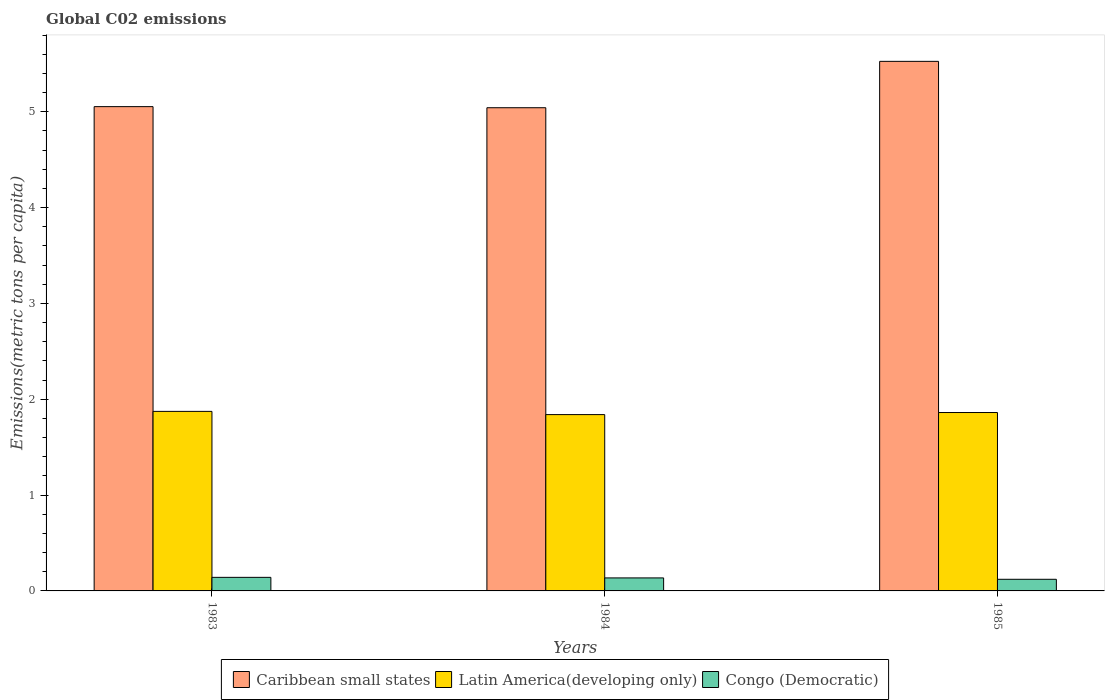Are the number of bars on each tick of the X-axis equal?
Your answer should be compact. Yes. In how many cases, is the number of bars for a given year not equal to the number of legend labels?
Your answer should be compact. 0. What is the amount of CO2 emitted in in Caribbean small states in 1984?
Make the answer very short. 5.04. Across all years, what is the maximum amount of CO2 emitted in in Congo (Democratic)?
Provide a short and direct response. 0.14. Across all years, what is the minimum amount of CO2 emitted in in Latin America(developing only)?
Give a very brief answer. 1.84. In which year was the amount of CO2 emitted in in Latin America(developing only) minimum?
Provide a short and direct response. 1984. What is the total amount of CO2 emitted in in Latin America(developing only) in the graph?
Your answer should be very brief. 5.57. What is the difference between the amount of CO2 emitted in in Caribbean small states in 1983 and that in 1984?
Your answer should be very brief. 0.01. What is the difference between the amount of CO2 emitted in in Caribbean small states in 1983 and the amount of CO2 emitted in in Latin America(developing only) in 1985?
Ensure brevity in your answer.  3.19. What is the average amount of CO2 emitted in in Latin America(developing only) per year?
Offer a very short reply. 1.86. In the year 1985, what is the difference between the amount of CO2 emitted in in Congo (Democratic) and amount of CO2 emitted in in Latin America(developing only)?
Ensure brevity in your answer.  -1.74. What is the ratio of the amount of CO2 emitted in in Congo (Democratic) in 1984 to that in 1985?
Ensure brevity in your answer.  1.12. What is the difference between the highest and the second highest amount of CO2 emitted in in Congo (Democratic)?
Ensure brevity in your answer.  0.01. What is the difference between the highest and the lowest amount of CO2 emitted in in Latin America(developing only)?
Your answer should be very brief. 0.03. In how many years, is the amount of CO2 emitted in in Caribbean small states greater than the average amount of CO2 emitted in in Caribbean small states taken over all years?
Make the answer very short. 1. Is the sum of the amount of CO2 emitted in in Latin America(developing only) in 1984 and 1985 greater than the maximum amount of CO2 emitted in in Caribbean small states across all years?
Keep it short and to the point. No. What does the 3rd bar from the left in 1985 represents?
Keep it short and to the point. Congo (Democratic). What does the 1st bar from the right in 1984 represents?
Make the answer very short. Congo (Democratic). How many bars are there?
Make the answer very short. 9. Are all the bars in the graph horizontal?
Offer a terse response. No. Are the values on the major ticks of Y-axis written in scientific E-notation?
Ensure brevity in your answer.  No. Does the graph contain any zero values?
Offer a very short reply. No. What is the title of the graph?
Offer a terse response. Global C02 emissions. What is the label or title of the Y-axis?
Give a very brief answer. Emissions(metric tons per capita). What is the Emissions(metric tons per capita) of Caribbean small states in 1983?
Provide a short and direct response. 5.05. What is the Emissions(metric tons per capita) of Latin America(developing only) in 1983?
Provide a succinct answer. 1.87. What is the Emissions(metric tons per capita) of Congo (Democratic) in 1983?
Make the answer very short. 0.14. What is the Emissions(metric tons per capita) of Caribbean small states in 1984?
Provide a succinct answer. 5.04. What is the Emissions(metric tons per capita) in Latin America(developing only) in 1984?
Offer a very short reply. 1.84. What is the Emissions(metric tons per capita) of Congo (Democratic) in 1984?
Provide a short and direct response. 0.14. What is the Emissions(metric tons per capita) of Caribbean small states in 1985?
Ensure brevity in your answer.  5.53. What is the Emissions(metric tons per capita) of Latin America(developing only) in 1985?
Your answer should be compact. 1.86. What is the Emissions(metric tons per capita) in Congo (Democratic) in 1985?
Offer a terse response. 0.12. Across all years, what is the maximum Emissions(metric tons per capita) in Caribbean small states?
Your response must be concise. 5.53. Across all years, what is the maximum Emissions(metric tons per capita) of Latin America(developing only)?
Give a very brief answer. 1.87. Across all years, what is the maximum Emissions(metric tons per capita) of Congo (Democratic)?
Offer a terse response. 0.14. Across all years, what is the minimum Emissions(metric tons per capita) of Caribbean small states?
Keep it short and to the point. 5.04. Across all years, what is the minimum Emissions(metric tons per capita) in Latin America(developing only)?
Provide a succinct answer. 1.84. Across all years, what is the minimum Emissions(metric tons per capita) of Congo (Democratic)?
Keep it short and to the point. 0.12. What is the total Emissions(metric tons per capita) of Caribbean small states in the graph?
Provide a short and direct response. 15.62. What is the total Emissions(metric tons per capita) in Latin America(developing only) in the graph?
Provide a succinct answer. 5.57. What is the total Emissions(metric tons per capita) in Congo (Democratic) in the graph?
Your answer should be very brief. 0.4. What is the difference between the Emissions(metric tons per capita) of Caribbean small states in 1983 and that in 1984?
Keep it short and to the point. 0.01. What is the difference between the Emissions(metric tons per capita) of Latin America(developing only) in 1983 and that in 1984?
Make the answer very short. 0.03. What is the difference between the Emissions(metric tons per capita) of Congo (Democratic) in 1983 and that in 1984?
Ensure brevity in your answer.  0.01. What is the difference between the Emissions(metric tons per capita) in Caribbean small states in 1983 and that in 1985?
Ensure brevity in your answer.  -0.47. What is the difference between the Emissions(metric tons per capita) in Latin America(developing only) in 1983 and that in 1985?
Offer a terse response. 0.01. What is the difference between the Emissions(metric tons per capita) of Congo (Democratic) in 1983 and that in 1985?
Provide a short and direct response. 0.02. What is the difference between the Emissions(metric tons per capita) of Caribbean small states in 1984 and that in 1985?
Your response must be concise. -0.48. What is the difference between the Emissions(metric tons per capita) of Latin America(developing only) in 1984 and that in 1985?
Ensure brevity in your answer.  -0.02. What is the difference between the Emissions(metric tons per capita) of Congo (Democratic) in 1984 and that in 1985?
Make the answer very short. 0.01. What is the difference between the Emissions(metric tons per capita) of Caribbean small states in 1983 and the Emissions(metric tons per capita) of Latin America(developing only) in 1984?
Keep it short and to the point. 3.21. What is the difference between the Emissions(metric tons per capita) in Caribbean small states in 1983 and the Emissions(metric tons per capita) in Congo (Democratic) in 1984?
Give a very brief answer. 4.92. What is the difference between the Emissions(metric tons per capita) of Latin America(developing only) in 1983 and the Emissions(metric tons per capita) of Congo (Democratic) in 1984?
Make the answer very short. 1.74. What is the difference between the Emissions(metric tons per capita) in Caribbean small states in 1983 and the Emissions(metric tons per capita) in Latin America(developing only) in 1985?
Make the answer very short. 3.19. What is the difference between the Emissions(metric tons per capita) in Caribbean small states in 1983 and the Emissions(metric tons per capita) in Congo (Democratic) in 1985?
Your response must be concise. 4.93. What is the difference between the Emissions(metric tons per capita) in Latin America(developing only) in 1983 and the Emissions(metric tons per capita) in Congo (Democratic) in 1985?
Provide a succinct answer. 1.75. What is the difference between the Emissions(metric tons per capita) of Caribbean small states in 1984 and the Emissions(metric tons per capita) of Latin America(developing only) in 1985?
Offer a very short reply. 3.18. What is the difference between the Emissions(metric tons per capita) of Caribbean small states in 1984 and the Emissions(metric tons per capita) of Congo (Democratic) in 1985?
Provide a short and direct response. 4.92. What is the difference between the Emissions(metric tons per capita) in Latin America(developing only) in 1984 and the Emissions(metric tons per capita) in Congo (Democratic) in 1985?
Your response must be concise. 1.72. What is the average Emissions(metric tons per capita) in Caribbean small states per year?
Give a very brief answer. 5.21. What is the average Emissions(metric tons per capita) of Latin America(developing only) per year?
Offer a very short reply. 1.86. What is the average Emissions(metric tons per capita) of Congo (Democratic) per year?
Offer a very short reply. 0.13. In the year 1983, what is the difference between the Emissions(metric tons per capita) in Caribbean small states and Emissions(metric tons per capita) in Latin America(developing only)?
Provide a succinct answer. 3.18. In the year 1983, what is the difference between the Emissions(metric tons per capita) in Caribbean small states and Emissions(metric tons per capita) in Congo (Democratic)?
Make the answer very short. 4.91. In the year 1983, what is the difference between the Emissions(metric tons per capita) in Latin America(developing only) and Emissions(metric tons per capita) in Congo (Democratic)?
Your response must be concise. 1.73. In the year 1984, what is the difference between the Emissions(metric tons per capita) of Caribbean small states and Emissions(metric tons per capita) of Latin America(developing only)?
Provide a succinct answer. 3.2. In the year 1984, what is the difference between the Emissions(metric tons per capita) in Caribbean small states and Emissions(metric tons per capita) in Congo (Democratic)?
Ensure brevity in your answer.  4.91. In the year 1984, what is the difference between the Emissions(metric tons per capita) in Latin America(developing only) and Emissions(metric tons per capita) in Congo (Democratic)?
Ensure brevity in your answer.  1.7. In the year 1985, what is the difference between the Emissions(metric tons per capita) in Caribbean small states and Emissions(metric tons per capita) in Latin America(developing only)?
Offer a terse response. 3.66. In the year 1985, what is the difference between the Emissions(metric tons per capita) of Caribbean small states and Emissions(metric tons per capita) of Congo (Democratic)?
Offer a very short reply. 5.4. In the year 1985, what is the difference between the Emissions(metric tons per capita) in Latin America(developing only) and Emissions(metric tons per capita) in Congo (Democratic)?
Keep it short and to the point. 1.74. What is the ratio of the Emissions(metric tons per capita) in Caribbean small states in 1983 to that in 1984?
Provide a succinct answer. 1. What is the ratio of the Emissions(metric tons per capita) in Latin America(developing only) in 1983 to that in 1984?
Ensure brevity in your answer.  1.02. What is the ratio of the Emissions(metric tons per capita) in Congo (Democratic) in 1983 to that in 1984?
Keep it short and to the point. 1.04. What is the ratio of the Emissions(metric tons per capita) in Caribbean small states in 1983 to that in 1985?
Your answer should be very brief. 0.91. What is the ratio of the Emissions(metric tons per capita) of Latin America(developing only) in 1983 to that in 1985?
Your response must be concise. 1.01. What is the ratio of the Emissions(metric tons per capita) of Congo (Democratic) in 1983 to that in 1985?
Your answer should be compact. 1.17. What is the ratio of the Emissions(metric tons per capita) of Caribbean small states in 1984 to that in 1985?
Ensure brevity in your answer.  0.91. What is the ratio of the Emissions(metric tons per capita) in Latin America(developing only) in 1984 to that in 1985?
Offer a very short reply. 0.99. What is the ratio of the Emissions(metric tons per capita) of Congo (Democratic) in 1984 to that in 1985?
Provide a short and direct response. 1.12. What is the difference between the highest and the second highest Emissions(metric tons per capita) of Caribbean small states?
Your answer should be very brief. 0.47. What is the difference between the highest and the second highest Emissions(metric tons per capita) in Latin America(developing only)?
Provide a succinct answer. 0.01. What is the difference between the highest and the second highest Emissions(metric tons per capita) of Congo (Democratic)?
Give a very brief answer. 0.01. What is the difference between the highest and the lowest Emissions(metric tons per capita) in Caribbean small states?
Provide a succinct answer. 0.48. What is the difference between the highest and the lowest Emissions(metric tons per capita) in Latin America(developing only)?
Your response must be concise. 0.03. What is the difference between the highest and the lowest Emissions(metric tons per capita) in Congo (Democratic)?
Your answer should be compact. 0.02. 